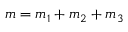<formula> <loc_0><loc_0><loc_500><loc_500>m = m _ { 1 } + m _ { 2 } + m _ { 3 }</formula> 